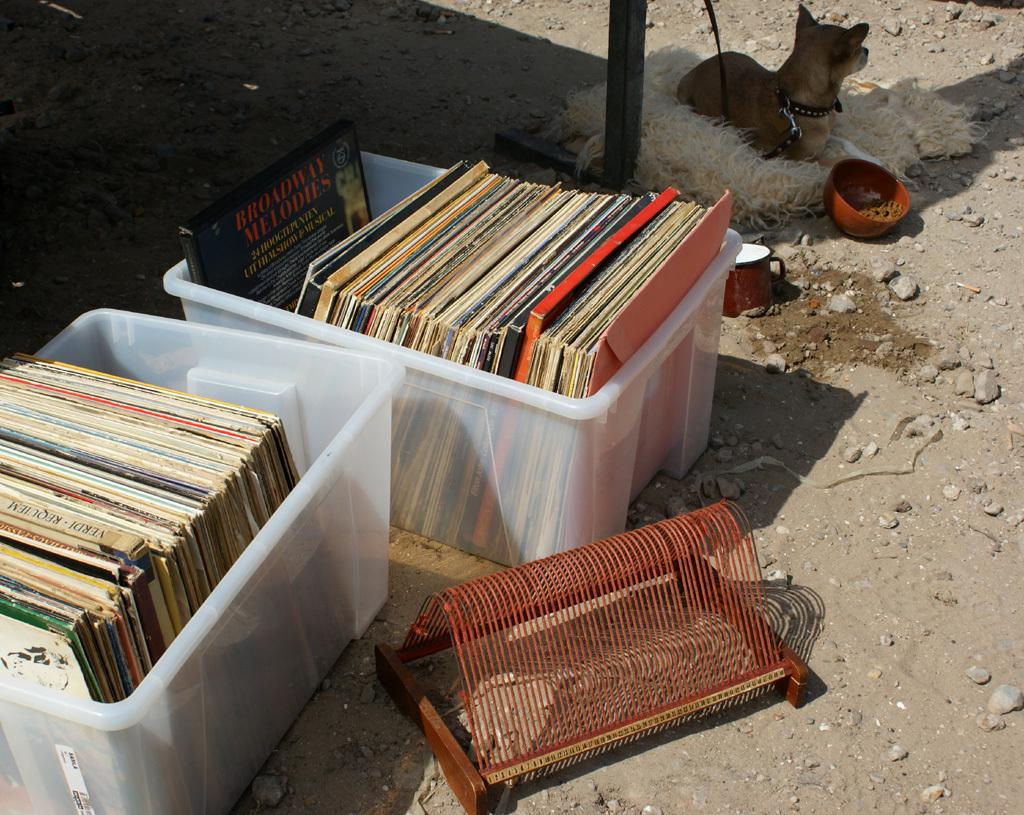What is located in the center of the image? There are books in a box in the center of the image. What type of animal can be seen in the image? There is a dog in the image. What is present at the bottom of the image? There is sand and stones at the bottom of the image. Where is the hospital located in the image? There is no hospital present in the image. How many chickens are visible in the image? There are no chickens present in the image. 